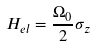<formula> <loc_0><loc_0><loc_500><loc_500>H _ { e l } = \frac { \Omega _ { 0 } } { 2 } \sigma _ { z }</formula> 